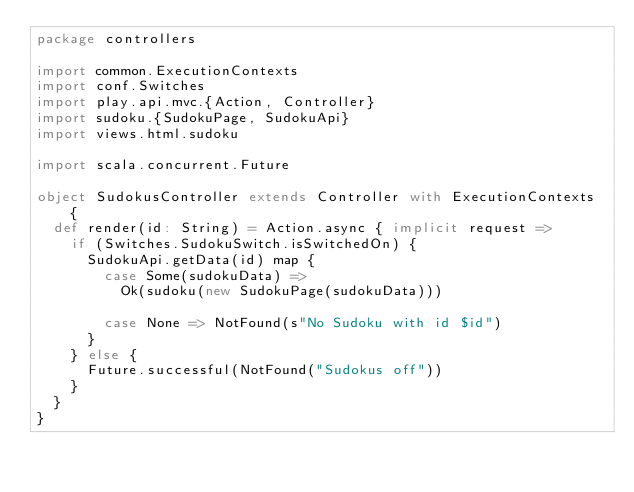Convert code to text. <code><loc_0><loc_0><loc_500><loc_500><_Scala_>package controllers

import common.ExecutionContexts
import conf.Switches
import play.api.mvc.{Action, Controller}
import sudoku.{SudokuPage, SudokuApi}
import views.html.sudoku

import scala.concurrent.Future

object SudokusController extends Controller with ExecutionContexts {
  def render(id: String) = Action.async { implicit request =>
    if (Switches.SudokuSwitch.isSwitchedOn) {
      SudokuApi.getData(id) map {
        case Some(sudokuData) =>
          Ok(sudoku(new SudokuPage(sudokuData)))

        case None => NotFound(s"No Sudoku with id $id")
      }
    } else {
      Future.successful(NotFound("Sudokus off"))
    }
  }
}
</code> 